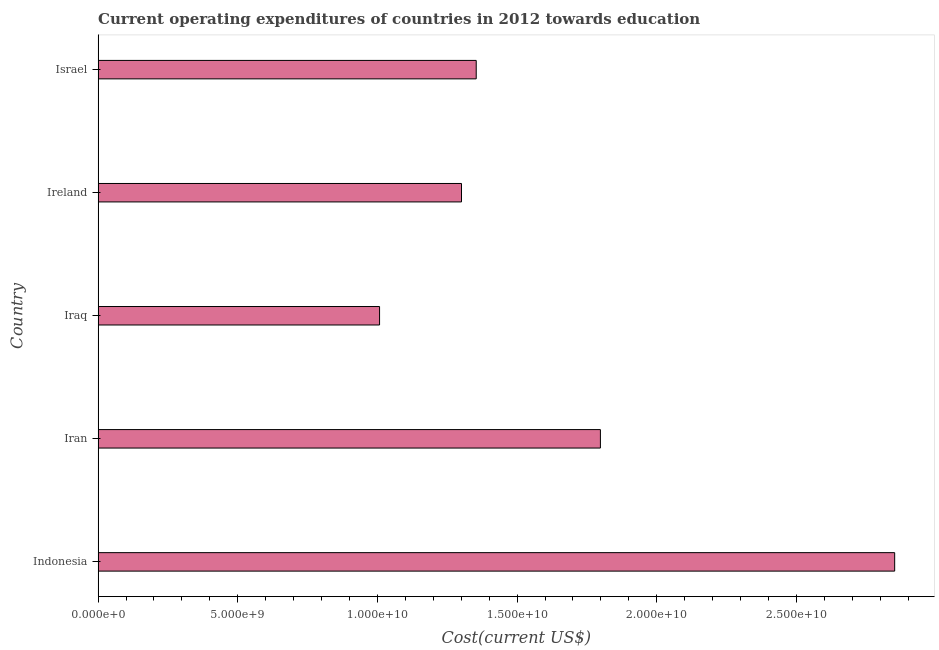Does the graph contain grids?
Ensure brevity in your answer.  No. What is the title of the graph?
Your answer should be compact. Current operating expenditures of countries in 2012 towards education. What is the label or title of the X-axis?
Give a very brief answer. Cost(current US$). What is the label or title of the Y-axis?
Ensure brevity in your answer.  Country. What is the education expenditure in Iraq?
Provide a succinct answer. 1.01e+1. Across all countries, what is the maximum education expenditure?
Keep it short and to the point. 2.85e+1. Across all countries, what is the minimum education expenditure?
Offer a very short reply. 1.01e+1. In which country was the education expenditure maximum?
Your response must be concise. Indonesia. In which country was the education expenditure minimum?
Offer a terse response. Iraq. What is the sum of the education expenditure?
Provide a short and direct response. 8.31e+1. What is the difference between the education expenditure in Indonesia and Israel?
Provide a succinct answer. 1.50e+1. What is the average education expenditure per country?
Your answer should be very brief. 1.66e+1. What is the median education expenditure?
Your answer should be compact. 1.35e+1. In how many countries, is the education expenditure greater than 9000000000 US$?
Your answer should be compact. 5. What is the ratio of the education expenditure in Iran to that in Israel?
Make the answer very short. 1.33. Is the education expenditure in Iraq less than that in Israel?
Your answer should be compact. Yes. What is the difference between the highest and the second highest education expenditure?
Make the answer very short. 1.05e+1. What is the difference between the highest and the lowest education expenditure?
Your answer should be compact. 1.84e+1. How many bars are there?
Make the answer very short. 5. What is the Cost(current US$) of Indonesia?
Keep it short and to the point. 2.85e+1. What is the Cost(current US$) in Iran?
Your answer should be very brief. 1.80e+1. What is the Cost(current US$) of Iraq?
Offer a very short reply. 1.01e+1. What is the Cost(current US$) of Ireland?
Provide a succinct answer. 1.30e+1. What is the Cost(current US$) of Israel?
Your response must be concise. 1.35e+1. What is the difference between the Cost(current US$) in Indonesia and Iran?
Offer a very short reply. 1.05e+1. What is the difference between the Cost(current US$) in Indonesia and Iraq?
Keep it short and to the point. 1.84e+1. What is the difference between the Cost(current US$) in Indonesia and Ireland?
Your answer should be very brief. 1.55e+1. What is the difference between the Cost(current US$) in Indonesia and Israel?
Your response must be concise. 1.50e+1. What is the difference between the Cost(current US$) in Iran and Iraq?
Your answer should be very brief. 7.91e+09. What is the difference between the Cost(current US$) in Iran and Ireland?
Your answer should be compact. 4.97e+09. What is the difference between the Cost(current US$) in Iran and Israel?
Provide a short and direct response. 4.45e+09. What is the difference between the Cost(current US$) in Iraq and Ireland?
Offer a terse response. -2.93e+09. What is the difference between the Cost(current US$) in Iraq and Israel?
Keep it short and to the point. -3.46e+09. What is the difference between the Cost(current US$) in Ireland and Israel?
Offer a very short reply. -5.27e+08. What is the ratio of the Cost(current US$) in Indonesia to that in Iran?
Give a very brief answer. 1.59. What is the ratio of the Cost(current US$) in Indonesia to that in Iraq?
Provide a short and direct response. 2.83. What is the ratio of the Cost(current US$) in Indonesia to that in Ireland?
Provide a short and direct response. 2.19. What is the ratio of the Cost(current US$) in Indonesia to that in Israel?
Make the answer very short. 2.11. What is the ratio of the Cost(current US$) in Iran to that in Iraq?
Give a very brief answer. 1.78. What is the ratio of the Cost(current US$) in Iran to that in Ireland?
Provide a short and direct response. 1.38. What is the ratio of the Cost(current US$) in Iran to that in Israel?
Your answer should be very brief. 1.33. What is the ratio of the Cost(current US$) in Iraq to that in Ireland?
Keep it short and to the point. 0.78. What is the ratio of the Cost(current US$) in Iraq to that in Israel?
Provide a succinct answer. 0.74. 